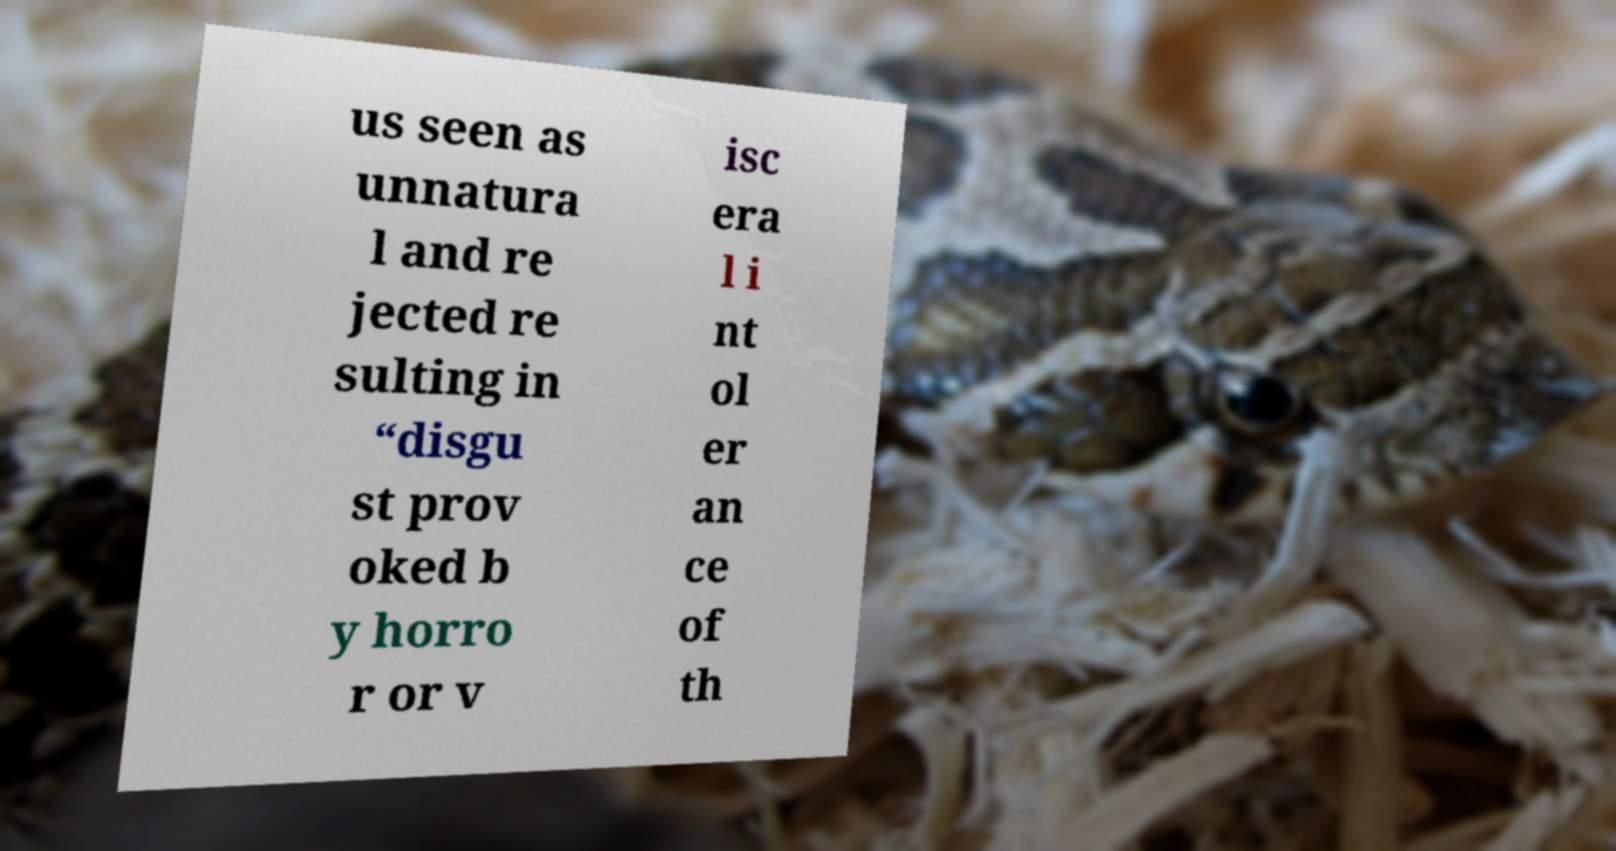What messages or text are displayed in this image? I need them in a readable, typed format. us seen as unnatura l and re jected re sulting in “disgu st prov oked b y horro r or v isc era l i nt ol er an ce of th 